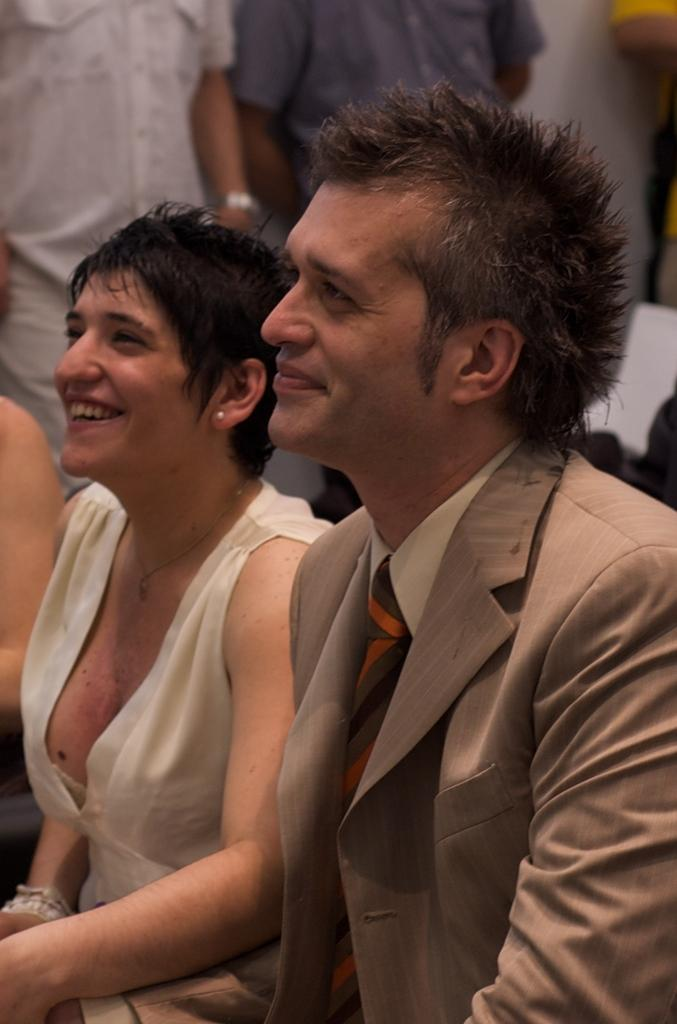How many people are present in the image? There are four people in the image, including a man and a woman who are sitting, and two people who are standing. What are the man and woman doing in the image? The man and woman are sitting. Can you describe the position of the two people who are standing? Unfortunately, the facts provided do not give any information about the position or actions of the two people who are standing. What type of honey is being served on the page in the image? There is no honey or page present in the image; it only features a man, a woman, and two people who are standing. 